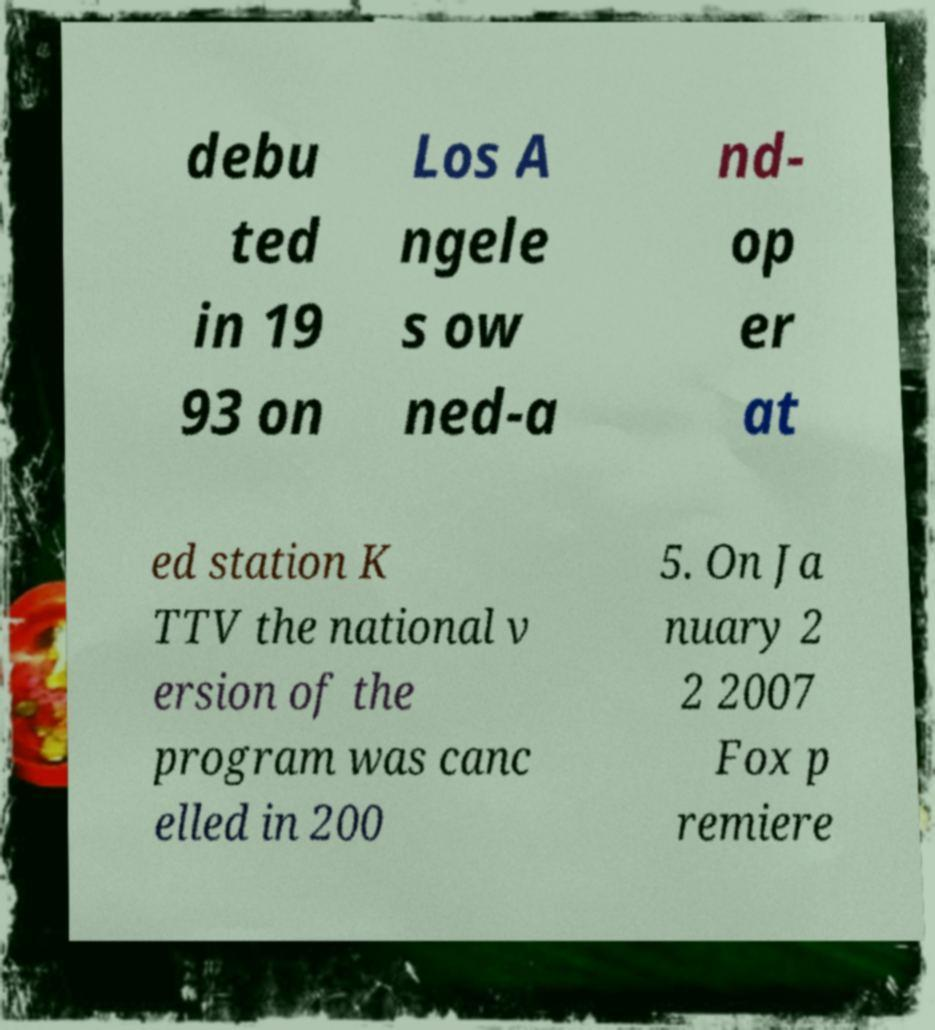For documentation purposes, I need the text within this image transcribed. Could you provide that? debu ted in 19 93 on Los A ngele s ow ned-a nd- op er at ed station K TTV the national v ersion of the program was canc elled in 200 5. On Ja nuary 2 2 2007 Fox p remiere 